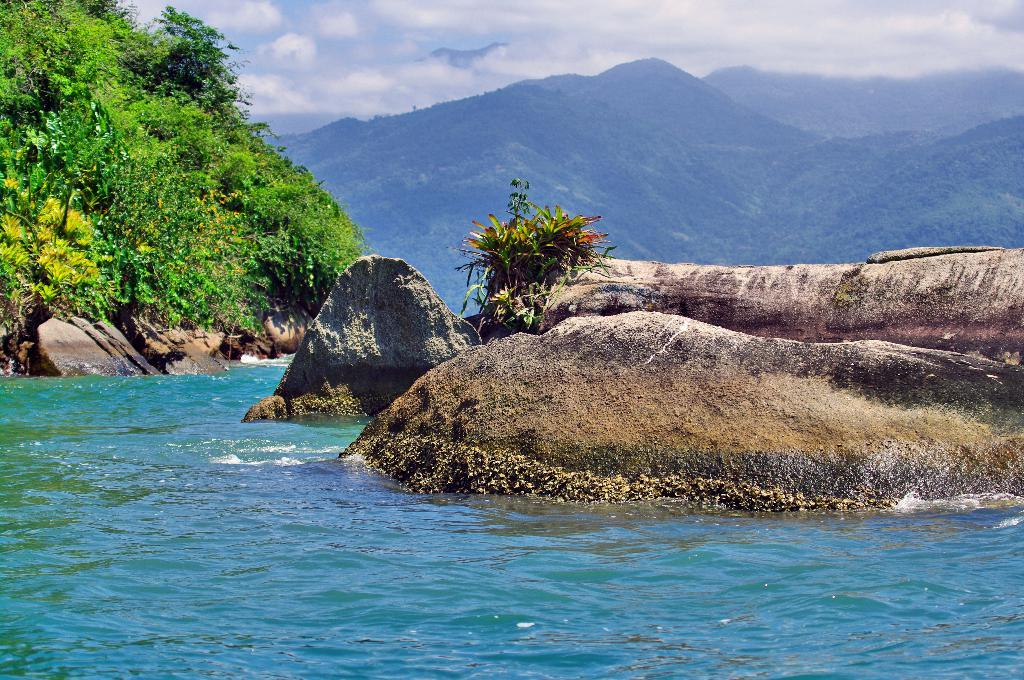What type of water body is visible in the image? There is a water body in the image, but the specific type is not mentioned. What other natural elements can be seen in the image? There is a group of plants and a rock visible in the image. What can be seen in the background of the image? There is a group of trees on the hills in the background of the image. How would you describe the sky in the image? The sky is visible in the image and appears cloudy. Where is the park located in the image? There is no park mentioned or visible in the image. How do the plants maintain their balance on the rock? The plants are not shown to be on the rock, and plants do not have the ability to balance themselves. 